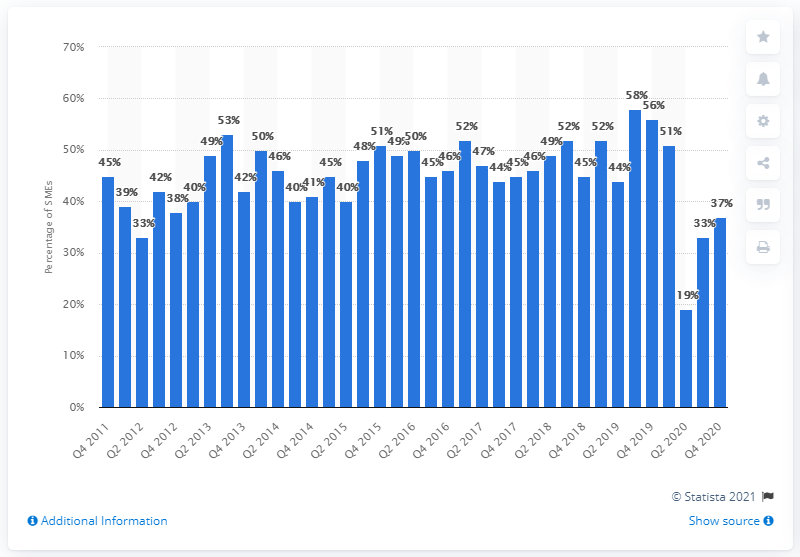Identify some key points in this picture. According to the survey of hospitality sector SMEs, 53% of them indicated that they plan to expand in the following 12 months. 